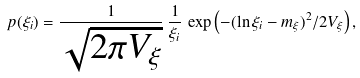Convert formula to latex. <formula><loc_0><loc_0><loc_500><loc_500>p ( \xi _ { i } ) = { \frac { 1 } { \sqrt { 2 \pi V _ { \xi } } } } \, { \frac { 1 } { \xi _ { i } } } \, \exp \left ( - ( \ln \xi _ { i } - m _ { \xi } ) ^ { 2 } / 2 V _ { \xi } \right ) ,</formula> 